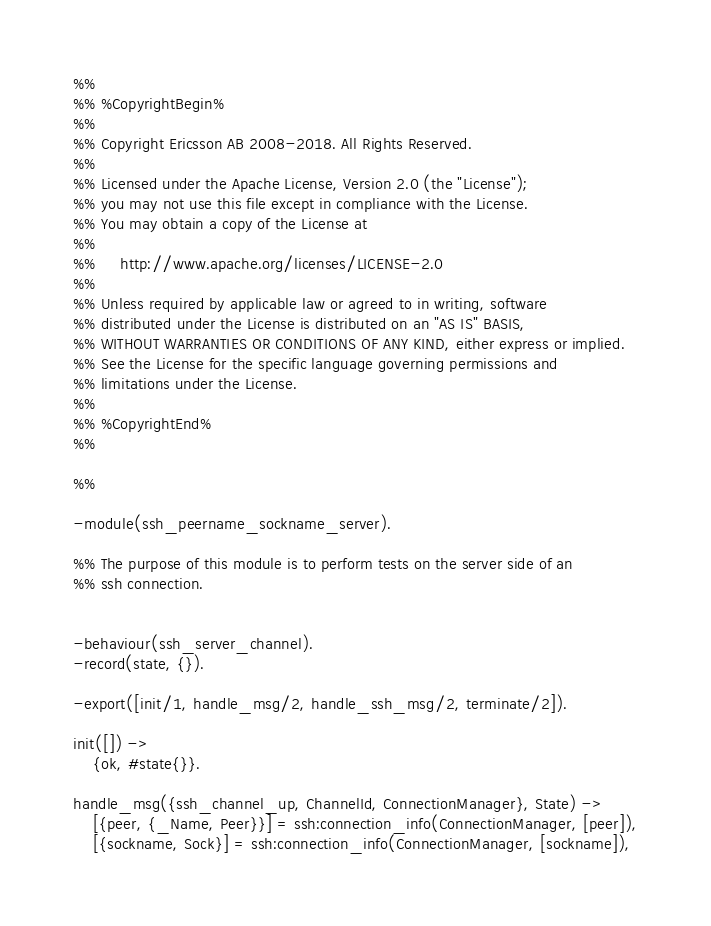<code> <loc_0><loc_0><loc_500><loc_500><_Erlang_>%%
%% %CopyrightBegin%
%%
%% Copyright Ericsson AB 2008-2018. All Rights Reserved.
%%
%% Licensed under the Apache License, Version 2.0 (the "License");
%% you may not use this file except in compliance with the License.
%% You may obtain a copy of the License at
%%
%%     http://www.apache.org/licenses/LICENSE-2.0
%%
%% Unless required by applicable law or agreed to in writing, software
%% distributed under the License is distributed on an "AS IS" BASIS,
%% WITHOUT WARRANTIES OR CONDITIONS OF ANY KIND, either express or implied.
%% See the License for the specific language governing permissions and
%% limitations under the License.
%%
%% %CopyrightEnd%
%%

%%

-module(ssh_peername_sockname_server).

%% The purpose of this module is to perform tests on the server side of an
%% ssh connection.


-behaviour(ssh_server_channel).
-record(state, {}).

-export([init/1, handle_msg/2, handle_ssh_msg/2, terminate/2]).

init([]) ->
    {ok, #state{}}.

handle_msg({ssh_channel_up, ChannelId, ConnectionManager}, State) ->
    [{peer, {_Name, Peer}}] = ssh:connection_info(ConnectionManager, [peer]),
    [{sockname, Sock}] = ssh:connection_info(ConnectionManager, [sockname]),</code> 